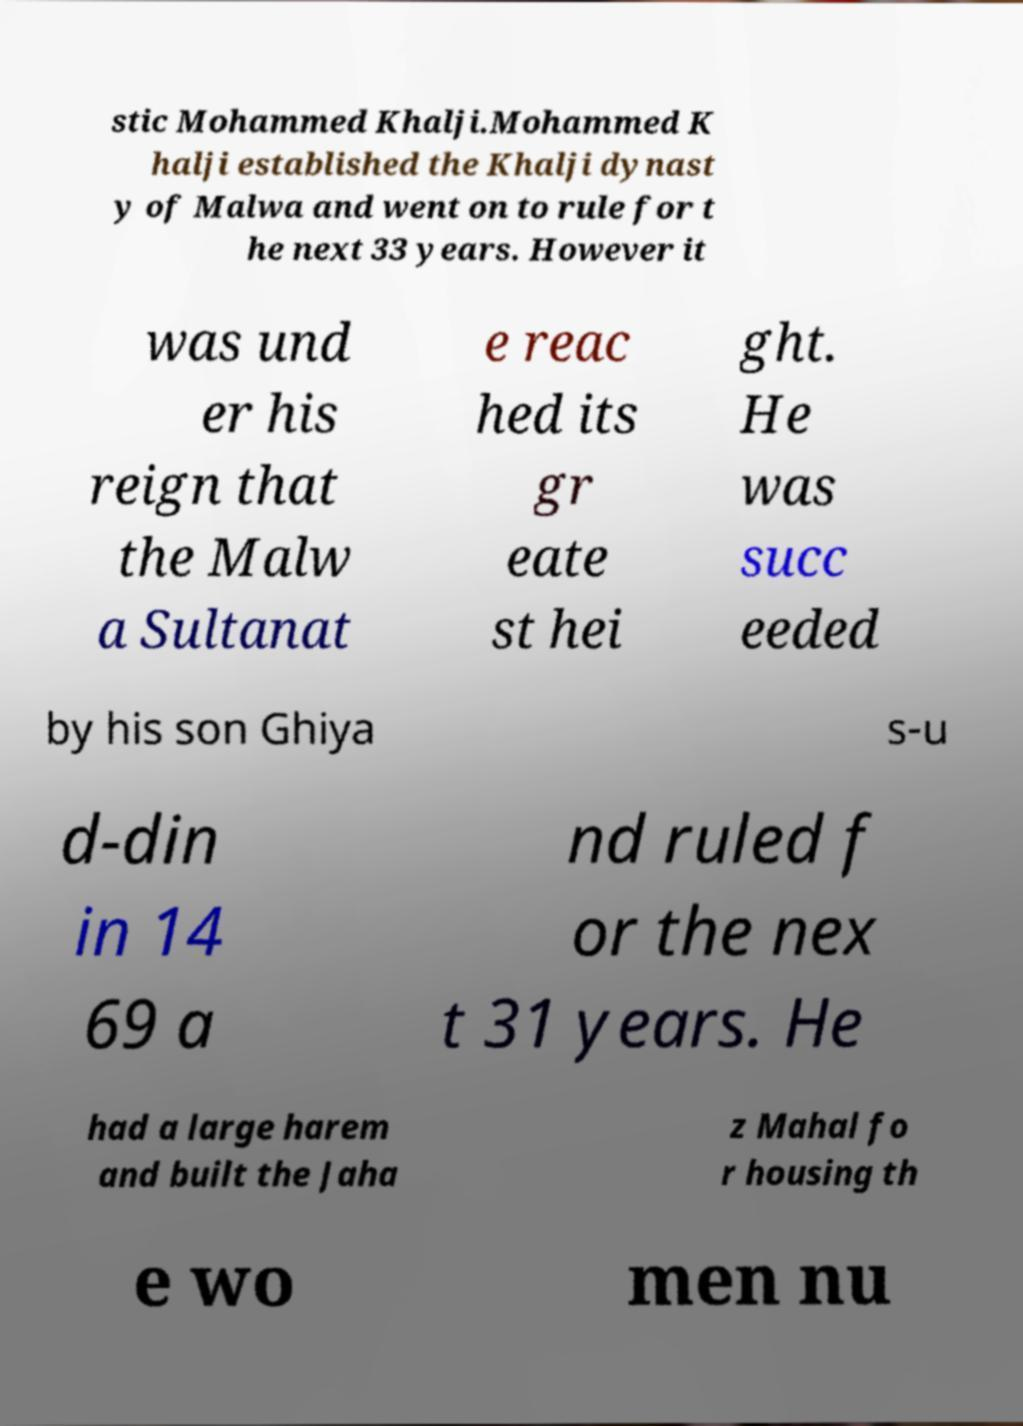There's text embedded in this image that I need extracted. Can you transcribe it verbatim? stic Mohammed Khalji.Mohammed K halji established the Khalji dynast y of Malwa and went on to rule for t he next 33 years. However it was und er his reign that the Malw a Sultanat e reac hed its gr eate st hei ght. He was succ eeded by his son Ghiya s-u d-din in 14 69 a nd ruled f or the nex t 31 years. He had a large harem and built the Jaha z Mahal fo r housing th e wo men nu 